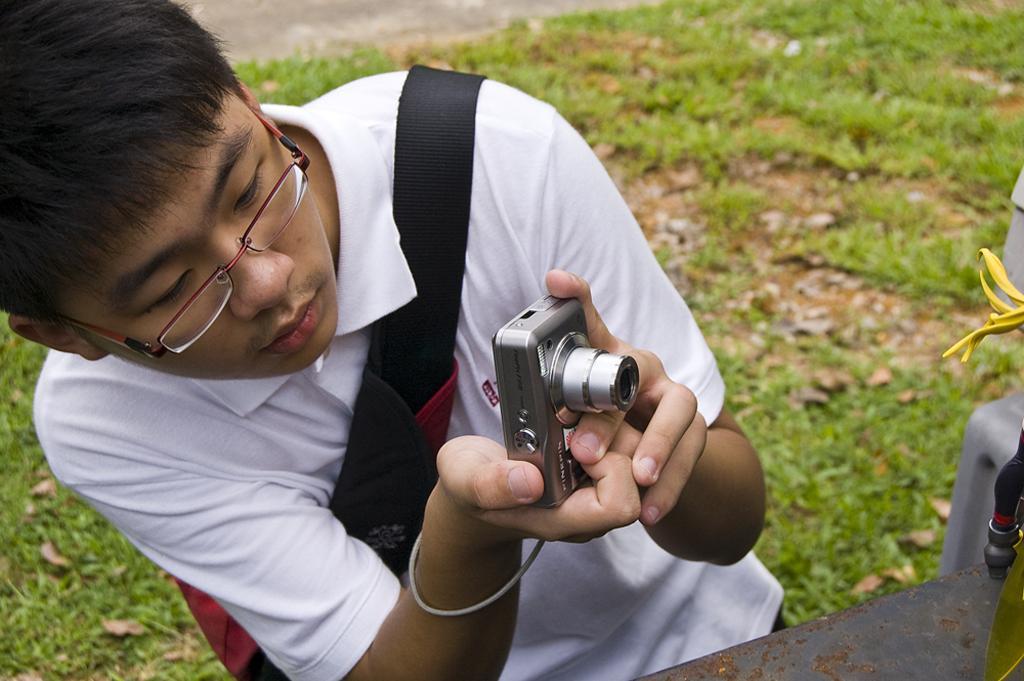Describe this image in one or two sentences. A boy is taking picture with a camera in his hand. 